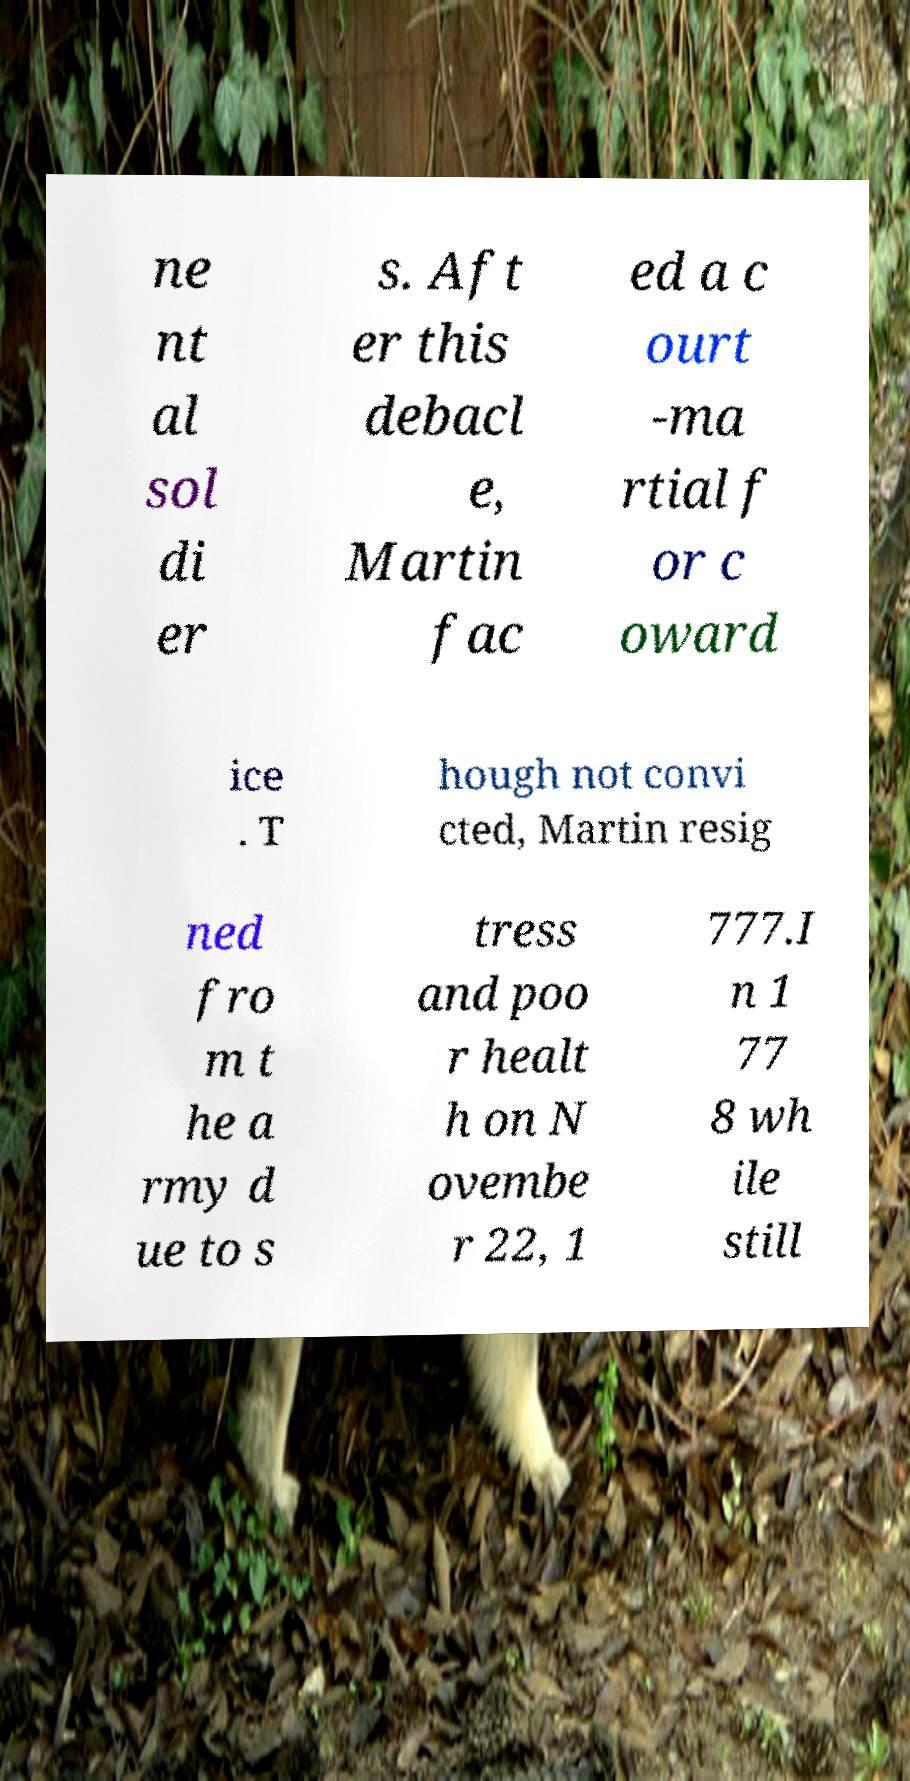I need the written content from this picture converted into text. Can you do that? ne nt al sol di er s. Aft er this debacl e, Martin fac ed a c ourt -ma rtial f or c oward ice . T hough not convi cted, Martin resig ned fro m t he a rmy d ue to s tress and poo r healt h on N ovembe r 22, 1 777.I n 1 77 8 wh ile still 